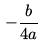Convert formula to latex. <formula><loc_0><loc_0><loc_500><loc_500>- \frac { b } { 4 a }</formula> 